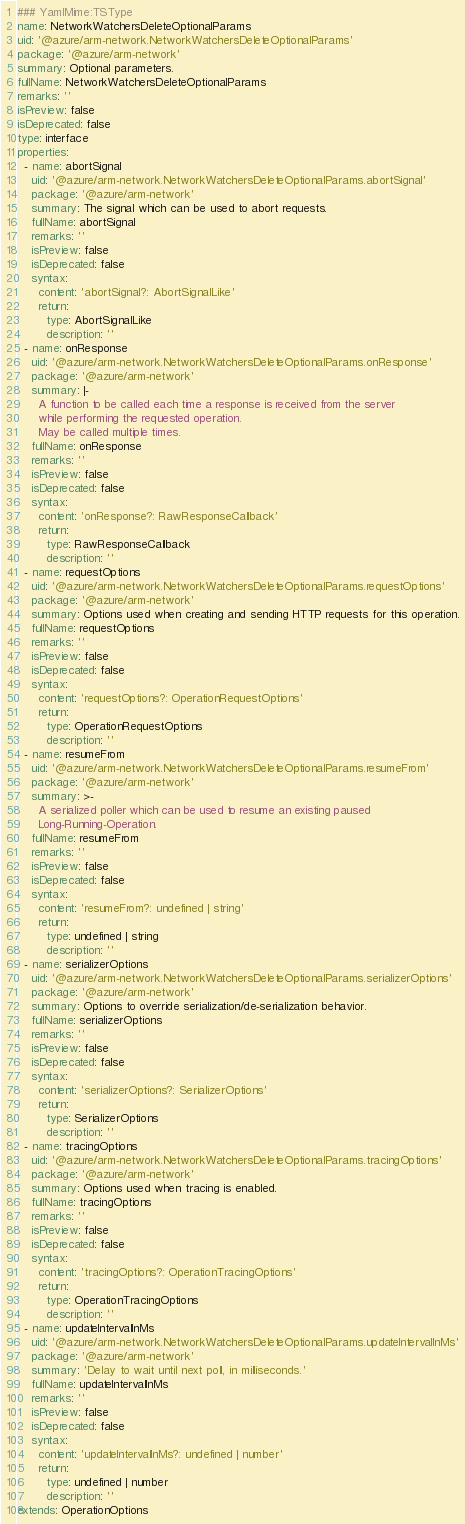<code> <loc_0><loc_0><loc_500><loc_500><_YAML_>### YamlMime:TSType
name: NetworkWatchersDeleteOptionalParams
uid: '@azure/arm-network.NetworkWatchersDeleteOptionalParams'
package: '@azure/arm-network'
summary: Optional parameters.
fullName: NetworkWatchersDeleteOptionalParams
remarks: ''
isPreview: false
isDeprecated: false
type: interface
properties:
  - name: abortSignal
    uid: '@azure/arm-network.NetworkWatchersDeleteOptionalParams.abortSignal'
    package: '@azure/arm-network'
    summary: The signal which can be used to abort requests.
    fullName: abortSignal
    remarks: ''
    isPreview: false
    isDeprecated: false
    syntax:
      content: 'abortSignal?: AbortSignalLike'
      return:
        type: AbortSignalLike
        description: ''
  - name: onResponse
    uid: '@azure/arm-network.NetworkWatchersDeleteOptionalParams.onResponse'
    package: '@azure/arm-network'
    summary: |-
      A function to be called each time a response is received from the server
      while performing the requested operation.
      May be called multiple times.
    fullName: onResponse
    remarks: ''
    isPreview: false
    isDeprecated: false
    syntax:
      content: 'onResponse?: RawResponseCallback'
      return:
        type: RawResponseCallback
        description: ''
  - name: requestOptions
    uid: '@azure/arm-network.NetworkWatchersDeleteOptionalParams.requestOptions'
    package: '@azure/arm-network'
    summary: Options used when creating and sending HTTP requests for this operation.
    fullName: requestOptions
    remarks: ''
    isPreview: false
    isDeprecated: false
    syntax:
      content: 'requestOptions?: OperationRequestOptions'
      return:
        type: OperationRequestOptions
        description: ''
  - name: resumeFrom
    uid: '@azure/arm-network.NetworkWatchersDeleteOptionalParams.resumeFrom'
    package: '@azure/arm-network'
    summary: >-
      A serialized poller which can be used to resume an existing paused
      Long-Running-Operation.
    fullName: resumeFrom
    remarks: ''
    isPreview: false
    isDeprecated: false
    syntax:
      content: 'resumeFrom?: undefined | string'
      return:
        type: undefined | string
        description: ''
  - name: serializerOptions
    uid: '@azure/arm-network.NetworkWatchersDeleteOptionalParams.serializerOptions'
    package: '@azure/arm-network'
    summary: Options to override serialization/de-serialization behavior.
    fullName: serializerOptions
    remarks: ''
    isPreview: false
    isDeprecated: false
    syntax:
      content: 'serializerOptions?: SerializerOptions'
      return:
        type: SerializerOptions
        description: ''
  - name: tracingOptions
    uid: '@azure/arm-network.NetworkWatchersDeleteOptionalParams.tracingOptions'
    package: '@azure/arm-network'
    summary: Options used when tracing is enabled.
    fullName: tracingOptions
    remarks: ''
    isPreview: false
    isDeprecated: false
    syntax:
      content: 'tracingOptions?: OperationTracingOptions'
      return:
        type: OperationTracingOptions
        description: ''
  - name: updateIntervalInMs
    uid: '@azure/arm-network.NetworkWatchersDeleteOptionalParams.updateIntervalInMs'
    package: '@azure/arm-network'
    summary: 'Delay to wait until next poll, in milliseconds.'
    fullName: updateIntervalInMs
    remarks: ''
    isPreview: false
    isDeprecated: false
    syntax:
      content: 'updateIntervalInMs?: undefined | number'
      return:
        type: undefined | number
        description: ''
extends: OperationOptions
</code> 